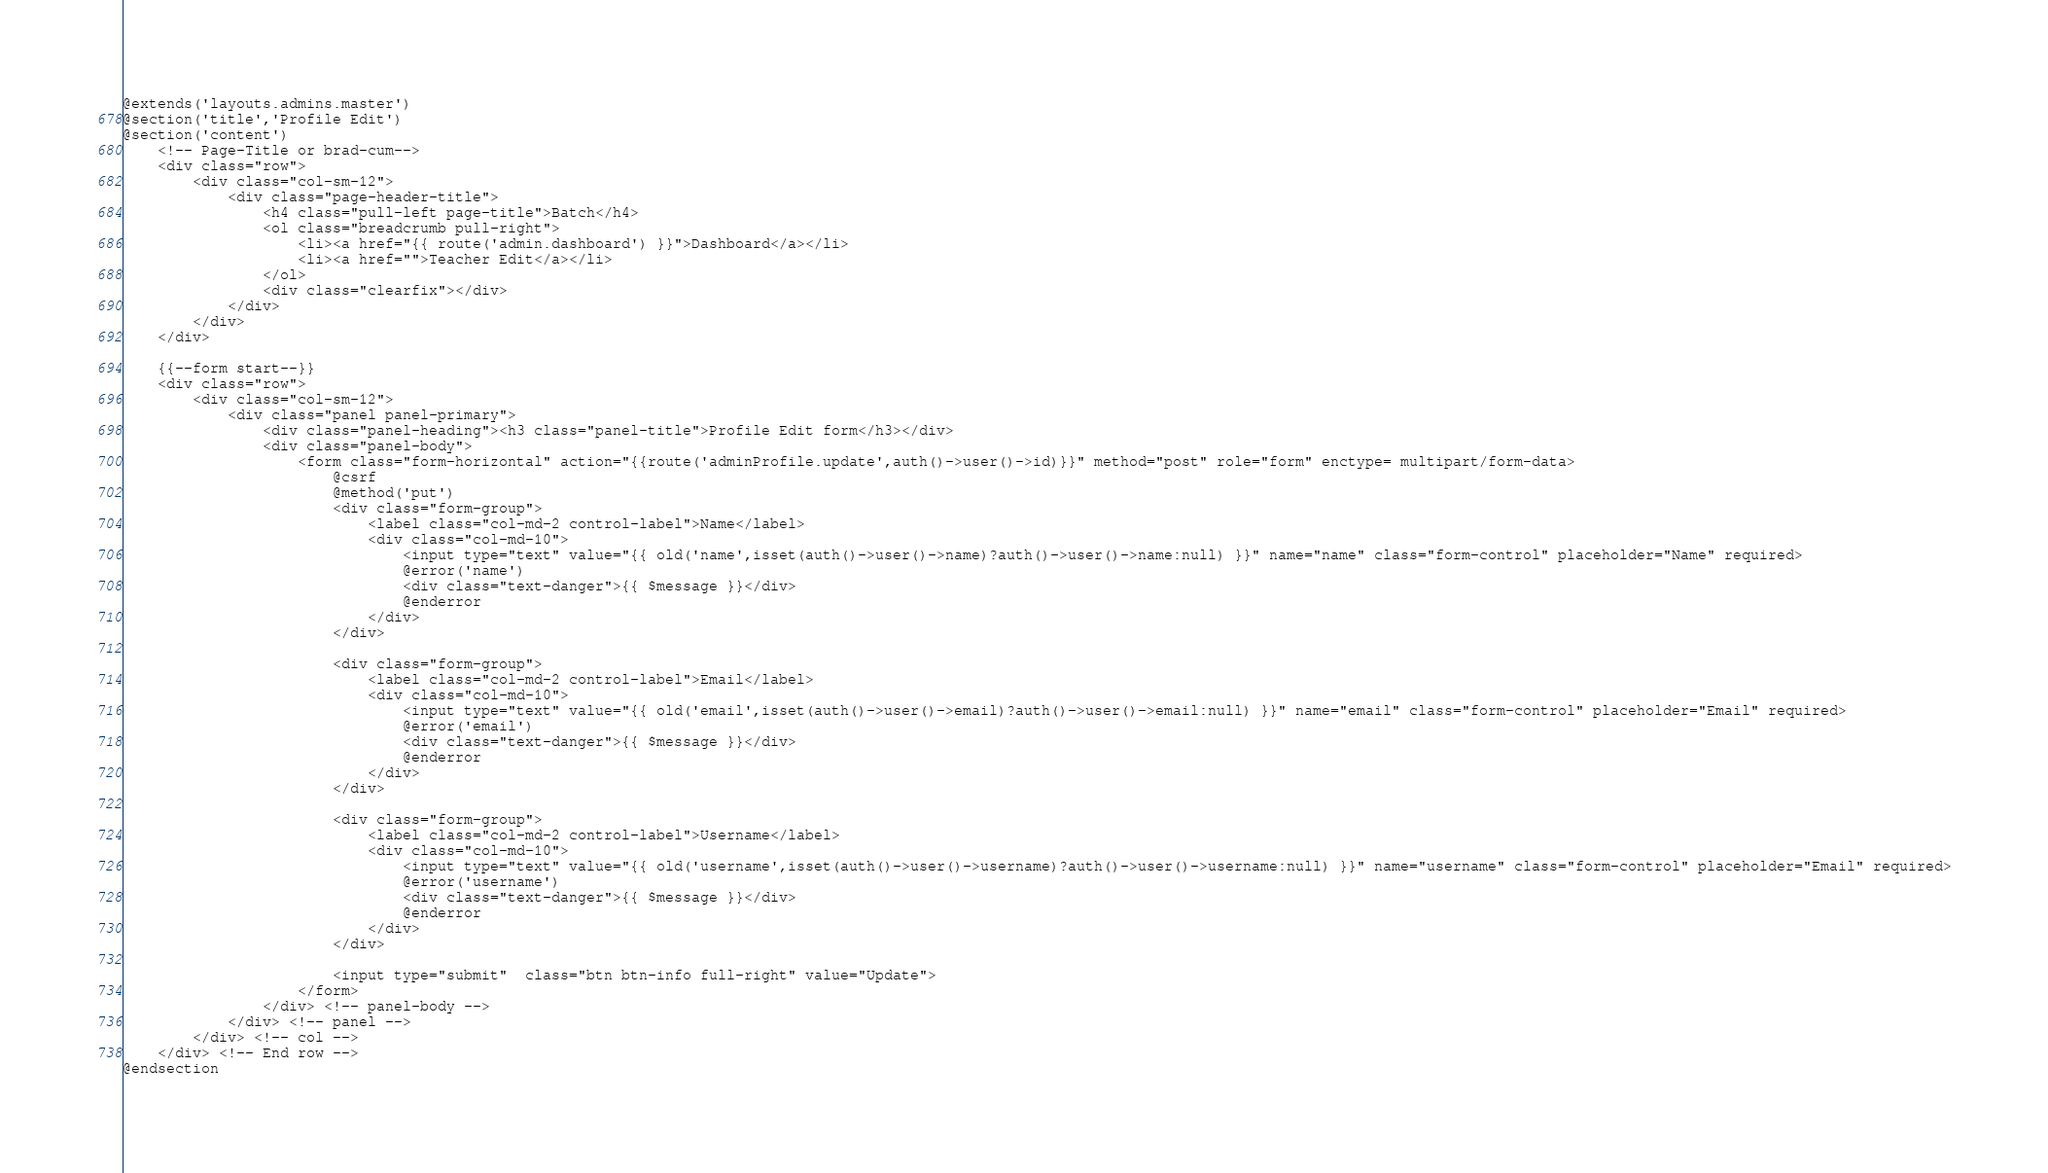<code> <loc_0><loc_0><loc_500><loc_500><_PHP_>@extends('layouts.admins.master')
@section('title','Profile Edit')
@section('content')
    <!-- Page-Title or brad-cum-->
    <div class="row">
        <div class="col-sm-12">
            <div class="page-header-title">
                <h4 class="pull-left page-title">Batch</h4>
                <ol class="breadcrumb pull-right">
                    <li><a href="{{ route('admin.dashboard') }}">Dashboard</a></li>
                    <li><a href="">Teacher Edit</a></li>
                </ol>
                <div class="clearfix"></div>
            </div>
        </div>
    </div>

    {{--form start--}}
    <div class="row">
        <div class="col-sm-12">
            <div class="panel panel-primary">
                <div class="panel-heading"><h3 class="panel-title">Profile Edit form</h3></div>
                <div class="panel-body">
                    <form class="form-horizontal" action="{{route('adminProfile.update',auth()->user()->id)}}" method="post" role="form" enctype= multipart/form-data>
                        @csrf
                        @method('put')
                        <div class="form-group">
                            <label class="col-md-2 control-label">Name</label>
                            <div class="col-md-10">
                                <input type="text" value="{{ old('name',isset(auth()->user()->name)?auth()->user()->name:null) }}" name="name" class="form-control" placeholder="Name" required>
                                @error('name')
                                <div class="text-danger">{{ $message }}</div>
                                @enderror
                            </div>
                        </div>

                        <div class="form-group">
                            <label class="col-md-2 control-label">Email</label>
                            <div class="col-md-10">
                                <input type="text" value="{{ old('email',isset(auth()->user()->email)?auth()->user()->email:null) }}" name="email" class="form-control" placeholder="Email" required>
                                @error('email')
                                <div class="text-danger">{{ $message }}</div>
                                @enderror
                            </div>
                        </div>

                        <div class="form-group">
                            <label class="col-md-2 control-label">Username</label>
                            <div class="col-md-10">
                                <input type="text" value="{{ old('username',isset(auth()->user()->username)?auth()->user()->username:null) }}" name="username" class="form-control" placeholder="Email" required>
                                @error('username')
                                <div class="text-danger">{{ $message }}</div>
                                @enderror
                            </div>
                        </div>

                        <input type="submit"  class="btn btn-info full-right" value="Update">
                    </form>
                </div> <!-- panel-body -->
            </div> <!-- panel -->
        </div> <!-- col -->
    </div> <!-- End row -->
@endsection</code> 